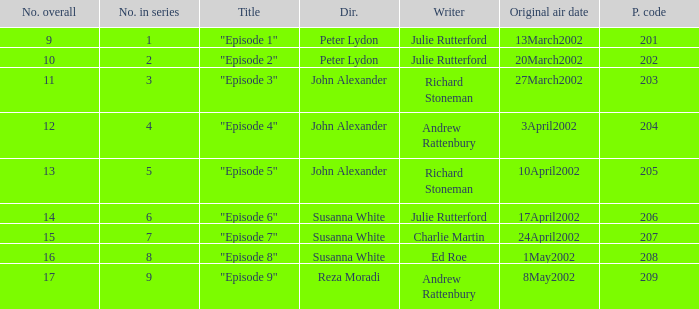When 1 is the number in series who is the director? Peter Lydon. 